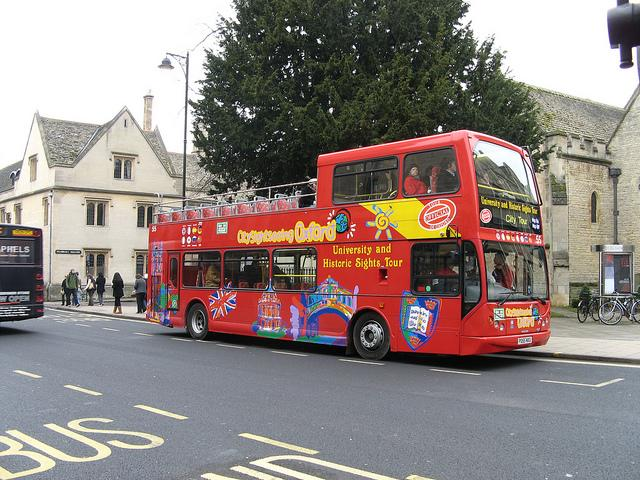Who are the passengers inside the red bus? Please explain your reasoning. tourists. The bust logo states it is a historic sights tour. 